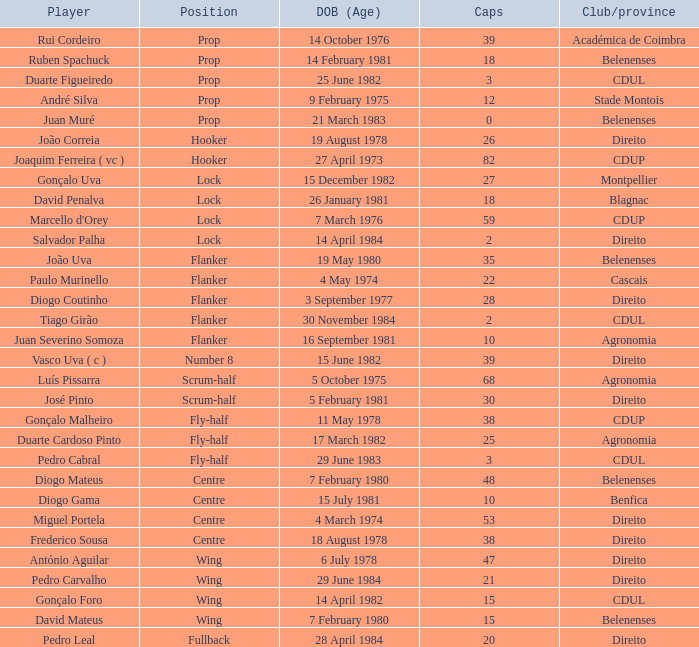Would you be able to parse every entry in this table? {'header': ['Player', 'Position', 'DOB (Age)', 'Caps', 'Club/province'], 'rows': [['Rui Cordeiro', 'Prop', '14 October 1976', '39', 'Académica de Coimbra'], ['Ruben Spachuck', 'Prop', '14 February 1981', '18', 'Belenenses'], ['Duarte Figueiredo', 'Prop', '25 June 1982', '3', 'CDUL'], ['André Silva', 'Prop', '9 February 1975', '12', 'Stade Montois'], ['Juan Muré', 'Prop', '21 March 1983', '0', 'Belenenses'], ['João Correia', 'Hooker', '19 August 1978', '26', 'Direito'], ['Joaquim Ferreira ( vc )', 'Hooker', '27 April 1973', '82', 'CDUP'], ['Gonçalo Uva', 'Lock', '15 December 1982', '27', 'Montpellier'], ['David Penalva', 'Lock', '26 January 1981', '18', 'Blagnac'], ["Marcello d'Orey", 'Lock', '7 March 1976', '59', 'CDUP'], ['Salvador Palha', 'Lock', '14 April 1984', '2', 'Direito'], ['João Uva', 'Flanker', '19 May 1980', '35', 'Belenenses'], ['Paulo Murinello', 'Flanker', '4 May 1974', '22', 'Cascais'], ['Diogo Coutinho', 'Flanker', '3 September 1977', '28', 'Direito'], ['Tiago Girão', 'Flanker', '30 November 1984', '2', 'CDUL'], ['Juan Severino Somoza', 'Flanker', '16 September 1981', '10', 'Agronomia'], ['Vasco Uva ( c )', 'Number 8', '15 June 1982', '39', 'Direito'], ['Luís Pissarra', 'Scrum-half', '5 October 1975', '68', 'Agronomia'], ['José Pinto', 'Scrum-half', '5 February 1981', '30', 'Direito'], ['Gonçalo Malheiro', 'Fly-half', '11 May 1978', '38', 'CDUP'], ['Duarte Cardoso Pinto', 'Fly-half', '17 March 1982', '25', 'Agronomia'], ['Pedro Cabral', 'Fly-half', '29 June 1983', '3', 'CDUL'], ['Diogo Mateus', 'Centre', '7 February 1980', '48', 'Belenenses'], ['Diogo Gama', 'Centre', '15 July 1981', '10', 'Benfica'], ['Miguel Portela', 'Centre', '4 March 1974', '53', 'Direito'], ['Frederico Sousa', 'Centre', '18 August 1978', '38', 'Direito'], ['António Aguilar', 'Wing', '6 July 1978', '47', 'Direito'], ['Pedro Carvalho', 'Wing', '29 June 1984', '21', 'Direito'], ['Gonçalo Foro', 'Wing', '14 April 1982', '15', 'CDUL'], ['David Mateus', 'Wing', '7 February 1980', '15', 'Belenenses'], ['Pedro Leal', 'Fullback', '28 April 1984', '20', 'Direito']]} How many caps have a Date of Birth (Age) of 15 july 1981? 1.0. 